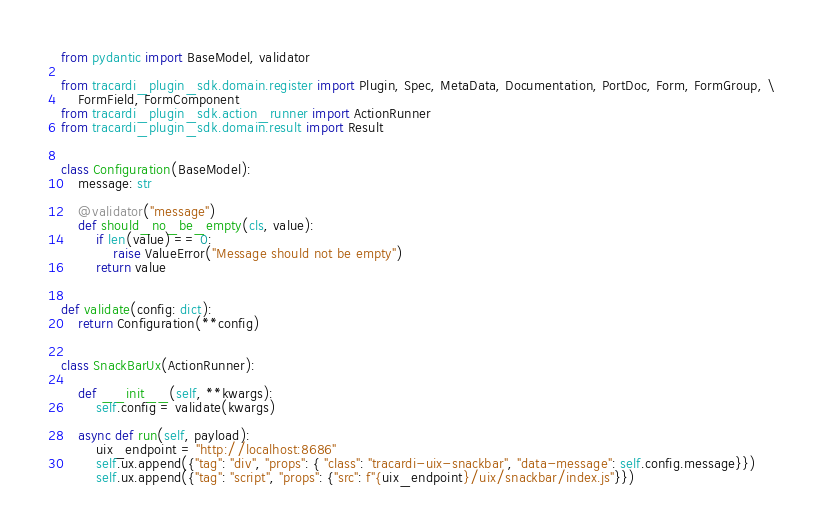<code> <loc_0><loc_0><loc_500><loc_500><_Python_>from pydantic import BaseModel, validator

from tracardi_plugin_sdk.domain.register import Plugin, Spec, MetaData, Documentation, PortDoc, Form, FormGroup, \
    FormField, FormComponent
from tracardi_plugin_sdk.action_runner import ActionRunner
from tracardi_plugin_sdk.domain.result import Result


class Configuration(BaseModel):
    message: str

    @validator("message")
    def should_no_be_empty(cls, value):
        if len(value) == 0:
            raise ValueError("Message should not be empty")
        return value


def validate(config: dict):
    return Configuration(**config)


class SnackBarUx(ActionRunner):

    def __init__(self, **kwargs):
        self.config = validate(kwargs)

    async def run(self, payload):
        uix_endpoint = "http://localhost:8686"
        self.ux.append({"tag": "div", "props": { "class": "tracardi-uix-snackbar", "data-message": self.config.message}})
        self.ux.append({"tag": "script", "props": {"src": f"{uix_endpoint}/uix/snackbar/index.js"}})
</code> 